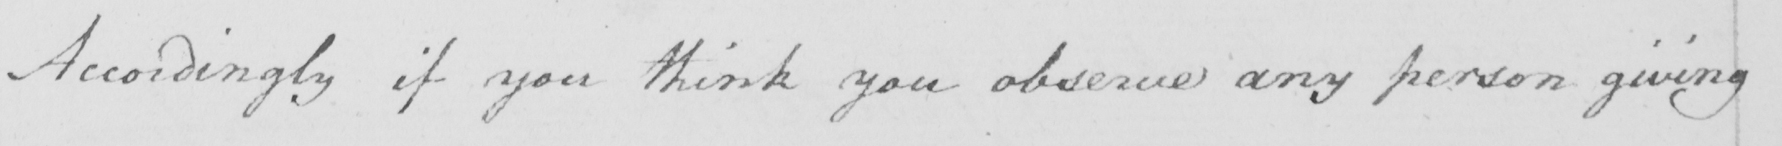Please transcribe the handwritten text in this image. Accordingly if you think you observe any person giving 